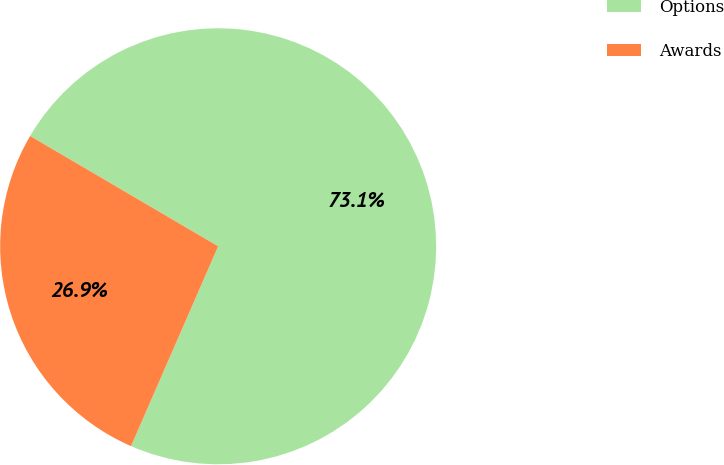Convert chart. <chart><loc_0><loc_0><loc_500><loc_500><pie_chart><fcel>Options<fcel>Awards<nl><fcel>73.1%<fcel>26.9%<nl></chart> 